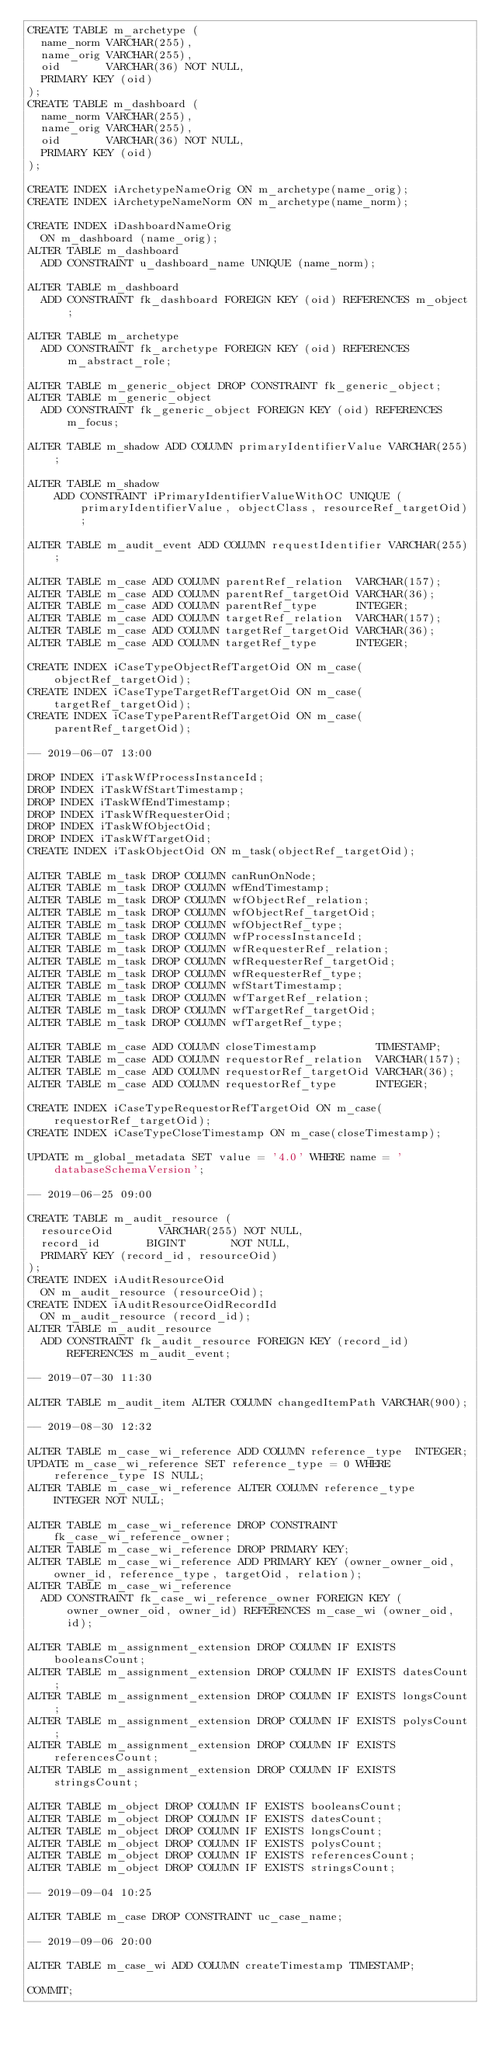<code> <loc_0><loc_0><loc_500><loc_500><_SQL_>CREATE TABLE m_archetype (
  name_norm VARCHAR(255),
  name_orig VARCHAR(255),
  oid       VARCHAR(36) NOT NULL,
  PRIMARY KEY (oid)
);
CREATE TABLE m_dashboard (
  name_norm VARCHAR(255),
  name_orig VARCHAR(255),
  oid       VARCHAR(36) NOT NULL,
  PRIMARY KEY (oid)
);

CREATE INDEX iArchetypeNameOrig ON m_archetype(name_orig);
CREATE INDEX iArchetypeNameNorm ON m_archetype(name_norm);

CREATE INDEX iDashboardNameOrig
  ON m_dashboard (name_orig);
ALTER TABLE m_dashboard
  ADD CONSTRAINT u_dashboard_name UNIQUE (name_norm);

ALTER TABLE m_dashboard
  ADD CONSTRAINT fk_dashboard FOREIGN KEY (oid) REFERENCES m_object;

ALTER TABLE m_archetype
  ADD CONSTRAINT fk_archetype FOREIGN KEY (oid) REFERENCES m_abstract_role;

ALTER TABLE m_generic_object DROP CONSTRAINT fk_generic_object;
ALTER TABLE m_generic_object
  ADD CONSTRAINT fk_generic_object FOREIGN KEY (oid) REFERENCES m_focus;

ALTER TABLE m_shadow ADD COLUMN primaryIdentifierValue VARCHAR(255);

ALTER TABLE m_shadow
    ADD CONSTRAINT iPrimaryIdentifierValueWithOC UNIQUE (primaryIdentifierValue, objectClass, resourceRef_targetOid);

ALTER TABLE m_audit_event ADD COLUMN requestIdentifier VARCHAR(255);

ALTER TABLE m_case ADD COLUMN parentRef_relation  VARCHAR(157);
ALTER TABLE m_case ADD COLUMN parentRef_targetOid VARCHAR(36);
ALTER TABLE m_case ADD COLUMN parentRef_type      INTEGER;
ALTER TABLE m_case ADD COLUMN targetRef_relation  VARCHAR(157);
ALTER TABLE m_case ADD COLUMN targetRef_targetOid VARCHAR(36);
ALTER TABLE m_case ADD COLUMN targetRef_type      INTEGER;

CREATE INDEX iCaseTypeObjectRefTargetOid ON m_case(objectRef_targetOid);
CREATE INDEX iCaseTypeTargetRefTargetOid ON m_case(targetRef_targetOid);
CREATE INDEX iCaseTypeParentRefTargetOid ON m_case(parentRef_targetOid);

-- 2019-06-07 13:00

DROP INDEX iTaskWfProcessInstanceId;
DROP INDEX iTaskWfStartTimestamp;
DROP INDEX iTaskWfEndTimestamp;
DROP INDEX iTaskWfRequesterOid;
DROP INDEX iTaskWfObjectOid;
DROP INDEX iTaskWfTargetOid;
CREATE INDEX iTaskObjectOid ON m_task(objectRef_targetOid);

ALTER TABLE m_task DROP COLUMN canRunOnNode;
ALTER TABLE m_task DROP COLUMN wfEndTimestamp;
ALTER TABLE m_task DROP COLUMN wfObjectRef_relation;
ALTER TABLE m_task DROP COLUMN wfObjectRef_targetOid;
ALTER TABLE m_task DROP COLUMN wfObjectRef_type;
ALTER TABLE m_task DROP COLUMN wfProcessInstanceId;
ALTER TABLE m_task DROP COLUMN wfRequesterRef_relation;
ALTER TABLE m_task DROP COLUMN wfRequesterRef_targetOid;
ALTER TABLE m_task DROP COLUMN wfRequesterRef_type;
ALTER TABLE m_task DROP COLUMN wfStartTimestamp;
ALTER TABLE m_task DROP COLUMN wfTargetRef_relation;
ALTER TABLE m_task DROP COLUMN wfTargetRef_targetOid;
ALTER TABLE m_task DROP COLUMN wfTargetRef_type;

ALTER TABLE m_case ADD COLUMN closeTimestamp         TIMESTAMP;
ALTER TABLE m_case ADD COLUMN requestorRef_relation  VARCHAR(157);
ALTER TABLE m_case ADD COLUMN requestorRef_targetOid VARCHAR(36);
ALTER TABLE m_case ADD COLUMN requestorRef_type      INTEGER;

CREATE INDEX iCaseTypeRequestorRefTargetOid ON m_case(requestorRef_targetOid);
CREATE INDEX iCaseTypeCloseTimestamp ON m_case(closeTimestamp);

UPDATE m_global_metadata SET value = '4.0' WHERE name = 'databaseSchemaVersion';

-- 2019-06-25 09:00

CREATE TABLE m_audit_resource (
  resourceOid       VARCHAR(255) NOT NULL,
  record_id       BIGINT       NOT NULL,
  PRIMARY KEY (record_id, resourceOid)
);
CREATE INDEX iAuditResourceOid
  ON m_audit_resource (resourceOid);
CREATE INDEX iAuditResourceOidRecordId
  ON m_audit_resource (record_id);
ALTER TABLE m_audit_resource
  ADD CONSTRAINT fk_audit_resource FOREIGN KEY (record_id) REFERENCES m_audit_event;

-- 2019-07-30 11:30

ALTER TABLE m_audit_item ALTER COLUMN changedItemPath VARCHAR(900);

-- 2019-08-30 12:32

ALTER TABLE m_case_wi_reference ADD COLUMN reference_type  INTEGER;
UPDATE m_case_wi_reference SET reference_type = 0 WHERE reference_type IS NULL;
ALTER TABLE m_case_wi_reference ALTER COLUMN reference_type  INTEGER NOT NULL;

ALTER TABLE m_case_wi_reference DROP CONSTRAINT fk_case_wi_reference_owner;
ALTER TABLE m_case_wi_reference DROP PRIMARY KEY;
ALTER TABLE m_case_wi_reference ADD PRIMARY KEY (owner_owner_oid, owner_id, reference_type, targetOid, relation);
ALTER TABLE m_case_wi_reference
  ADD CONSTRAINT fk_case_wi_reference_owner FOREIGN KEY (owner_owner_oid, owner_id) REFERENCES m_case_wi (owner_oid, id);

ALTER TABLE m_assignment_extension DROP COLUMN IF EXISTS booleansCount;
ALTER TABLE m_assignment_extension DROP COLUMN IF EXISTS datesCount;
ALTER TABLE m_assignment_extension DROP COLUMN IF EXISTS longsCount;
ALTER TABLE m_assignment_extension DROP COLUMN IF EXISTS polysCount;
ALTER TABLE m_assignment_extension DROP COLUMN IF EXISTS referencesCount;
ALTER TABLE m_assignment_extension DROP COLUMN IF EXISTS stringsCount;

ALTER TABLE m_object DROP COLUMN IF EXISTS booleansCount;
ALTER TABLE m_object DROP COLUMN IF EXISTS datesCount;
ALTER TABLE m_object DROP COLUMN IF EXISTS longsCount;
ALTER TABLE m_object DROP COLUMN IF EXISTS polysCount;
ALTER TABLE m_object DROP COLUMN IF EXISTS referencesCount;
ALTER TABLE m_object DROP COLUMN IF EXISTS stringsCount;

-- 2019-09-04 10:25

ALTER TABLE m_case DROP CONSTRAINT uc_case_name;

-- 2019-09-06 20:00

ALTER TABLE m_case_wi ADD COLUMN createTimestamp TIMESTAMP;

COMMIT;
</code> 